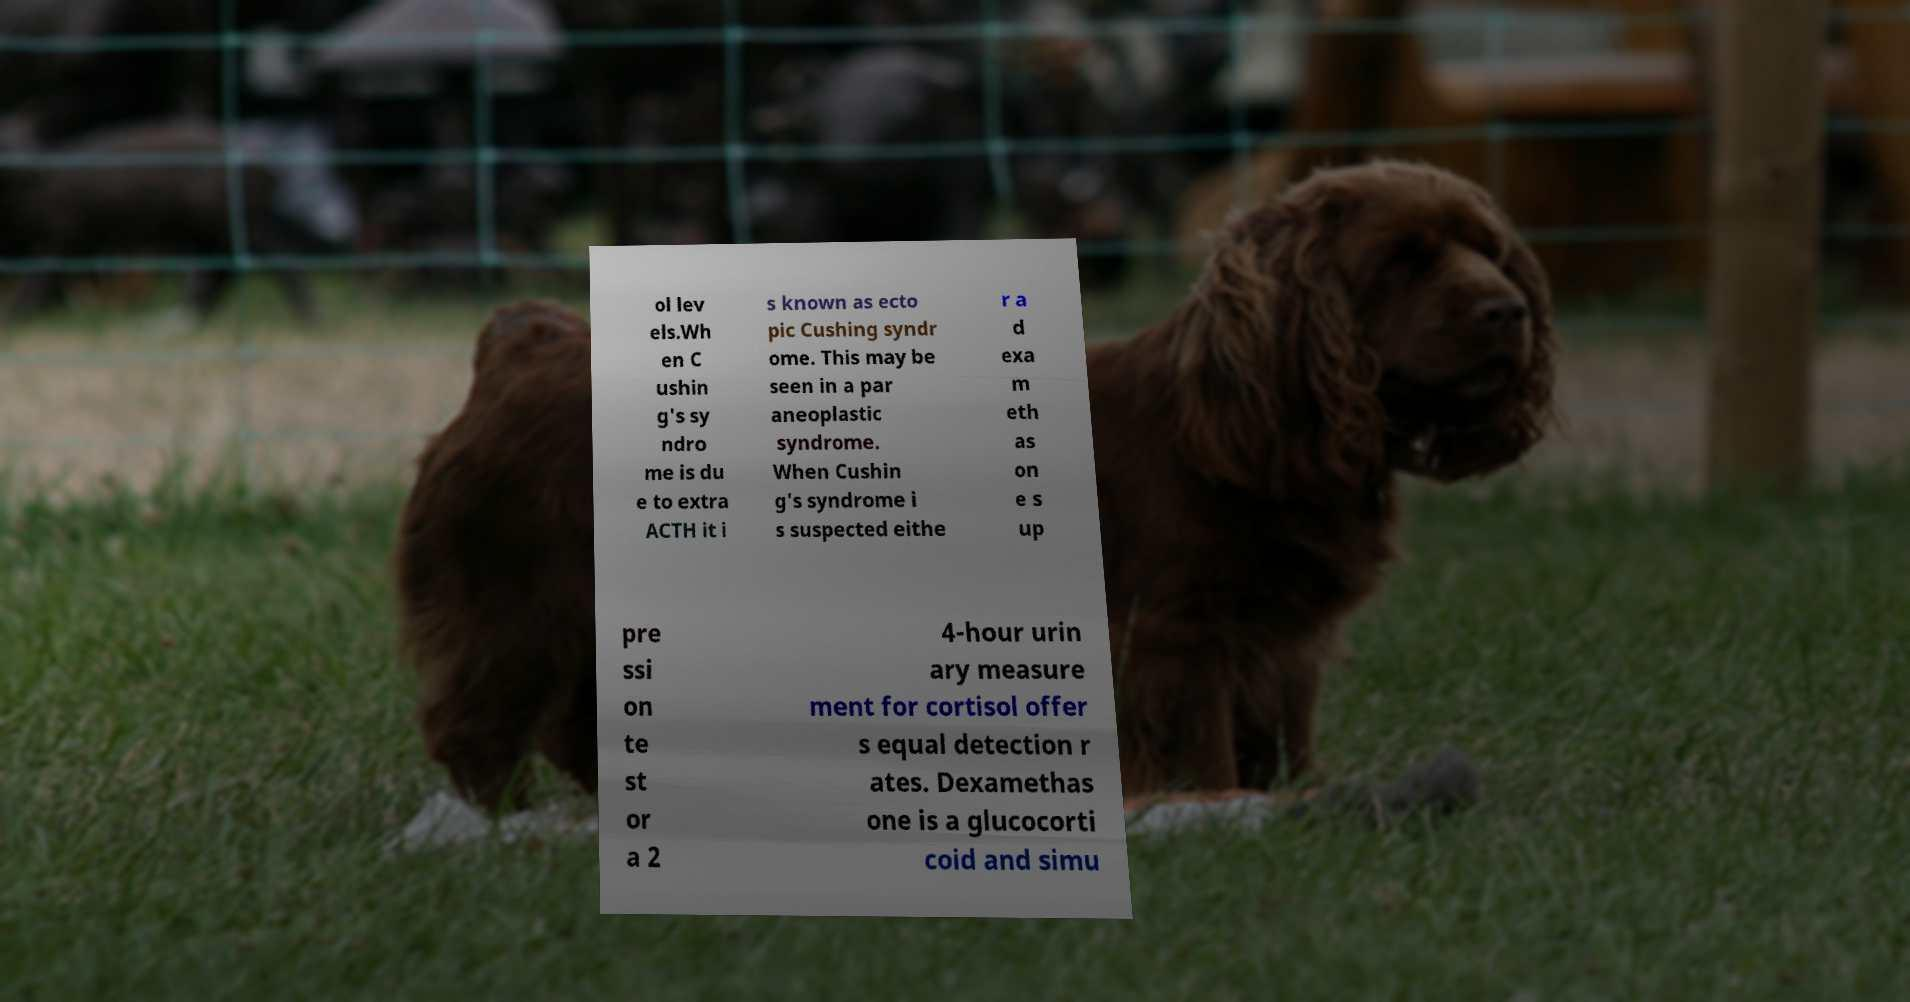Please identify and transcribe the text found in this image. ol lev els.Wh en C ushin g's sy ndro me is du e to extra ACTH it i s known as ecto pic Cushing syndr ome. This may be seen in a par aneoplastic syndrome. When Cushin g's syndrome i s suspected eithe r a d exa m eth as on e s up pre ssi on te st or a 2 4-hour urin ary measure ment for cortisol offer s equal detection r ates. Dexamethas one is a glucocorti coid and simu 